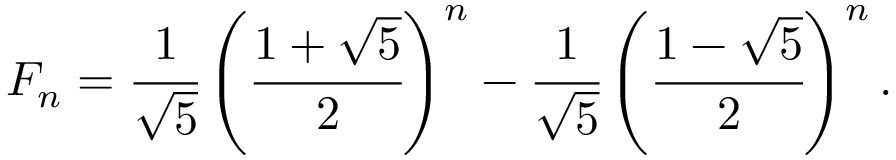Convert formula to latex. <formula><loc_0><loc_0><loc_500><loc_500>F _ { n } = { \cfrac { 1 } { \sqrt { 5 } } } \left ( { \cfrac { 1 + { \sqrt { 5 } } } { 2 } } \right ) ^ { n } - { \cfrac { 1 } { \sqrt { 5 } } } \left ( { \cfrac { 1 - { \sqrt { 5 } } } { 2 } } \right ) ^ { n } .</formula> 